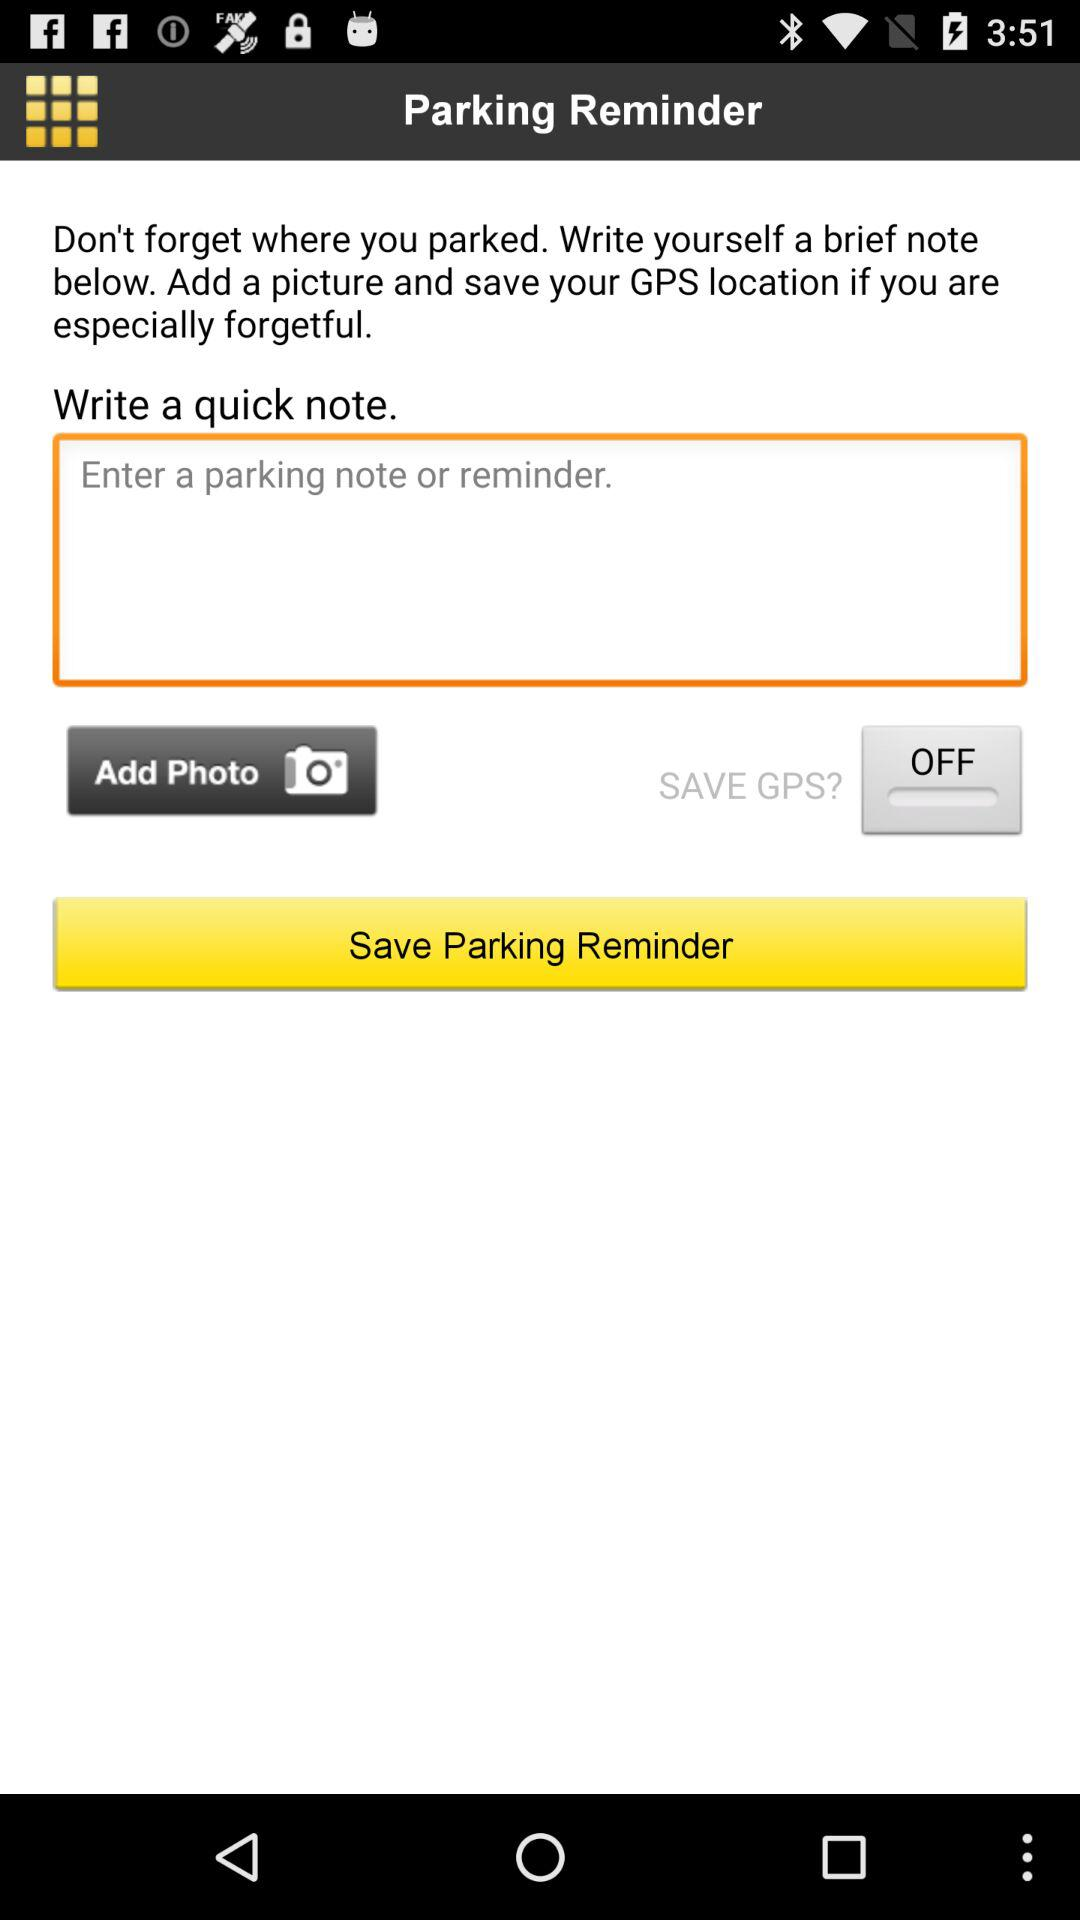What's the SAVE GPS status? The status is "OFF". 